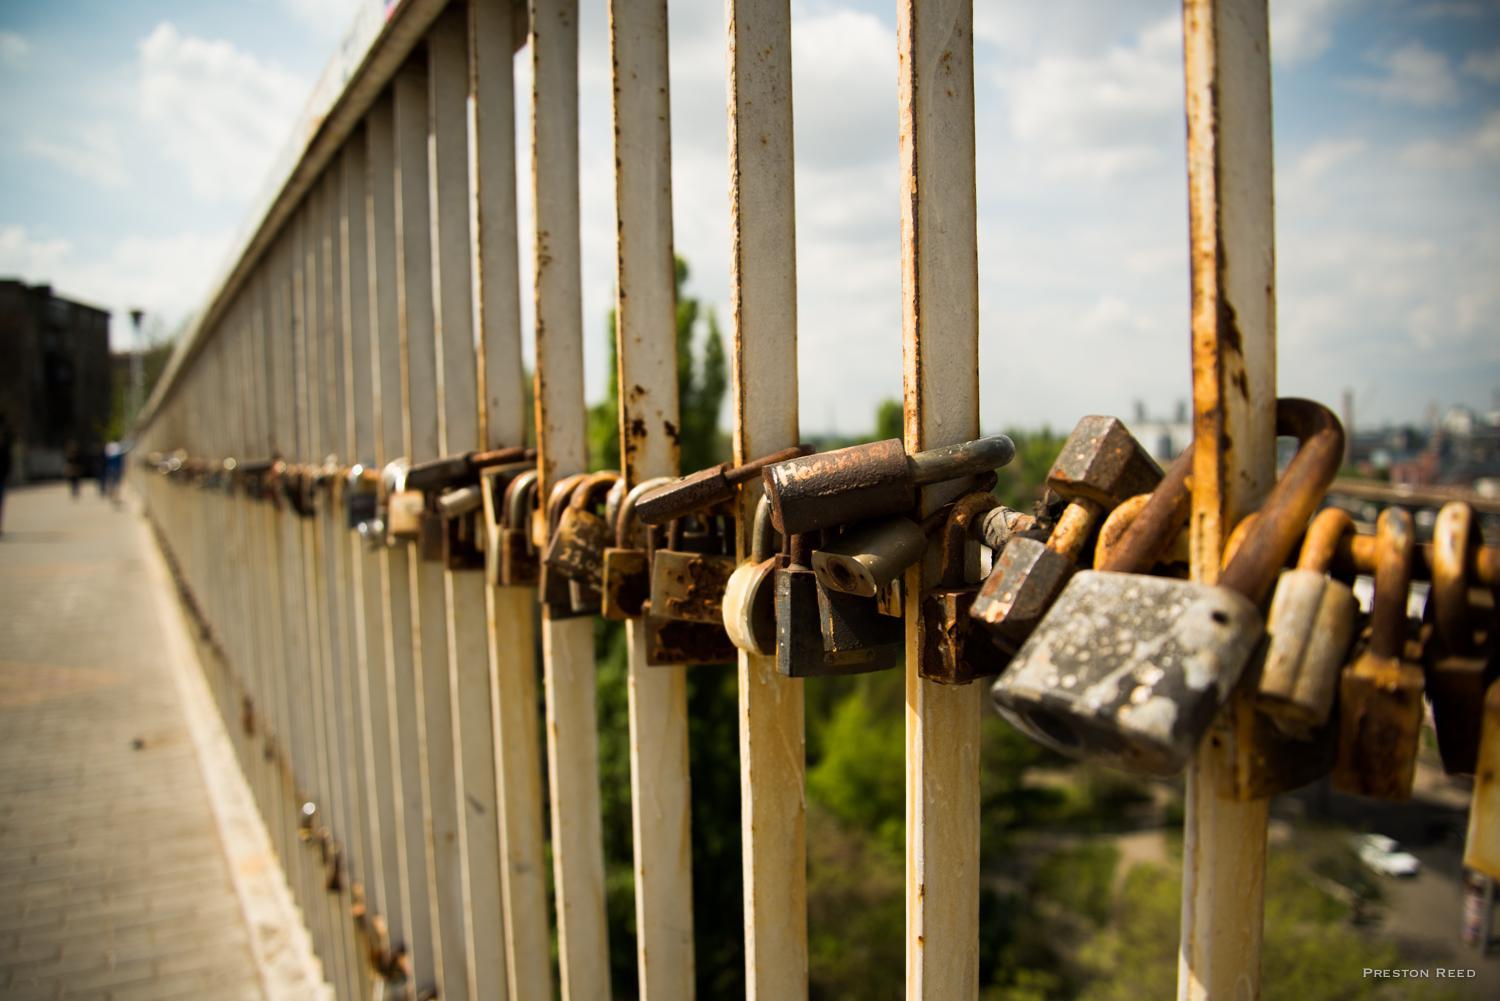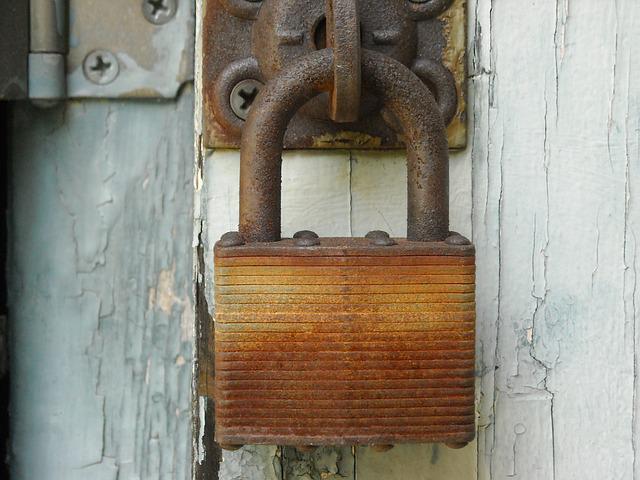The first image is the image on the left, the second image is the image on the right. For the images shown, is this caption "There is one lock without a key in the right image." true? Answer yes or no. Yes. The first image is the image on the left, the second image is the image on the right. For the images shown, is this caption "There is more than one lock in the right image." true? Answer yes or no. No. 